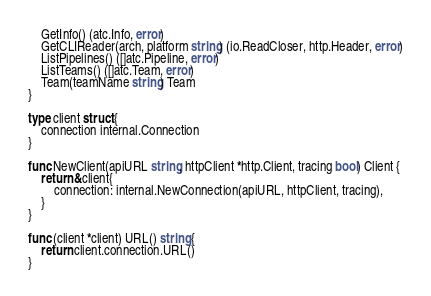<code> <loc_0><loc_0><loc_500><loc_500><_Go_>	GetInfo() (atc.Info, error)
	GetCLIReader(arch, platform string) (io.ReadCloser, http.Header, error)
	ListPipelines() ([]atc.Pipeline, error)
	ListTeams() ([]atc.Team, error)
	Team(teamName string) Team
}

type client struct {
	connection internal.Connection
}

func NewClient(apiURL string, httpClient *http.Client, tracing bool) Client {
	return &client{
		connection: internal.NewConnection(apiURL, httpClient, tracing),
	}
}

func (client *client) URL() string {
	return client.connection.URL()
}
</code> 